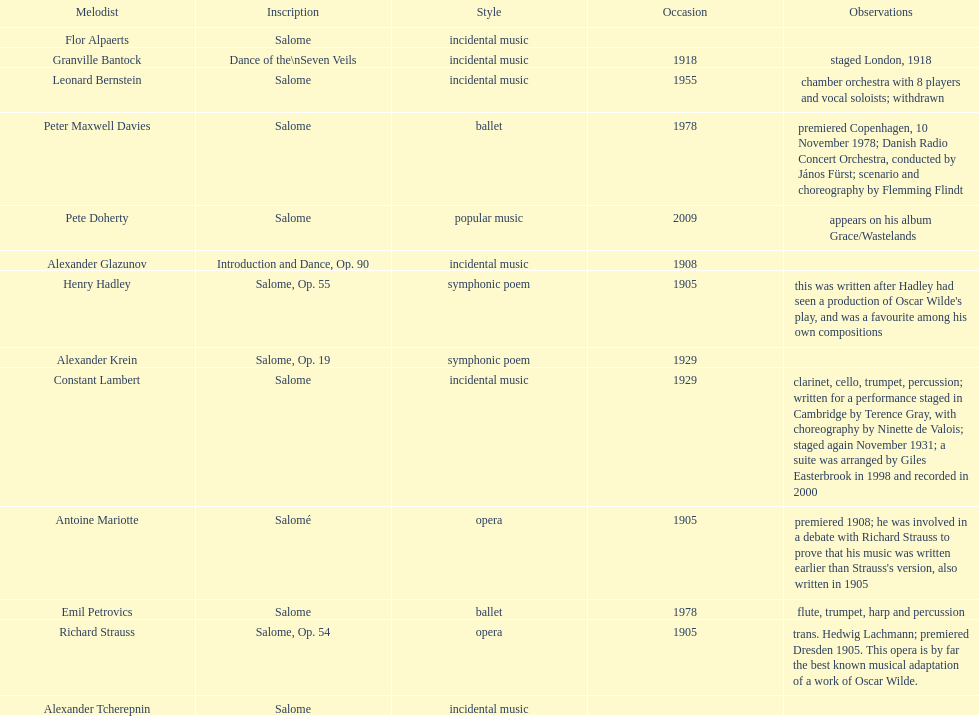How many are symphonic poems? 2. 